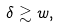Convert formula to latex. <formula><loc_0><loc_0><loc_500><loc_500>\delta \gtrsim w ,</formula> 